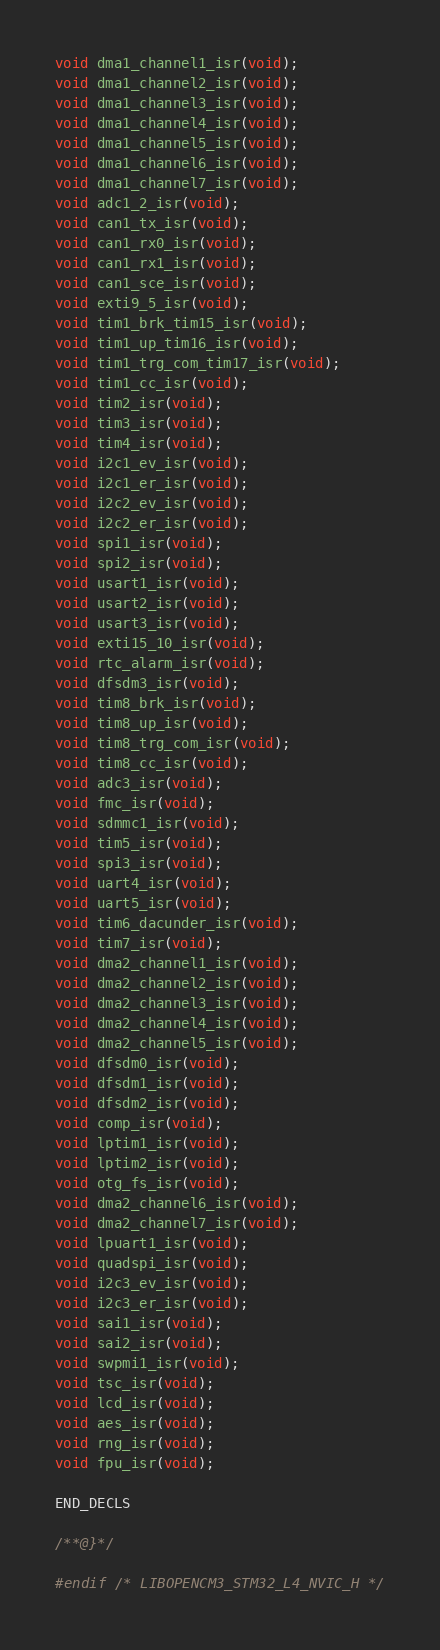<code> <loc_0><loc_0><loc_500><loc_500><_C_>void dma1_channel1_isr(void);
void dma1_channel2_isr(void);
void dma1_channel3_isr(void);
void dma1_channel4_isr(void);
void dma1_channel5_isr(void);
void dma1_channel6_isr(void);
void dma1_channel7_isr(void);
void adc1_2_isr(void);
void can1_tx_isr(void);
void can1_rx0_isr(void);
void can1_rx1_isr(void);
void can1_sce_isr(void);
void exti9_5_isr(void);
void tim1_brk_tim15_isr(void);
void tim1_up_tim16_isr(void);
void tim1_trg_com_tim17_isr(void);
void tim1_cc_isr(void);
void tim2_isr(void);
void tim3_isr(void);
void tim4_isr(void);
void i2c1_ev_isr(void);
void i2c1_er_isr(void);
void i2c2_ev_isr(void);
void i2c2_er_isr(void);
void spi1_isr(void);
void spi2_isr(void);
void usart1_isr(void);
void usart2_isr(void);
void usart3_isr(void);
void exti15_10_isr(void);
void rtc_alarm_isr(void);
void dfsdm3_isr(void);
void tim8_brk_isr(void);
void tim8_up_isr(void);
void tim8_trg_com_isr(void);
void tim8_cc_isr(void);
void adc3_isr(void);
void fmc_isr(void);
void sdmmc1_isr(void);
void tim5_isr(void);
void spi3_isr(void);
void uart4_isr(void);
void uart5_isr(void);
void tim6_dacunder_isr(void);
void tim7_isr(void);
void dma2_channel1_isr(void);
void dma2_channel2_isr(void);
void dma2_channel3_isr(void);
void dma2_channel4_isr(void);
void dma2_channel5_isr(void);
void dfsdm0_isr(void);
void dfsdm1_isr(void);
void dfsdm2_isr(void);
void comp_isr(void);
void lptim1_isr(void);
void lptim2_isr(void);
void otg_fs_isr(void);
void dma2_channel6_isr(void);
void dma2_channel7_isr(void);
void lpuart1_isr(void);
void quadspi_isr(void);
void i2c3_ev_isr(void);
void i2c3_er_isr(void);
void sai1_isr(void);
void sai2_isr(void);
void swpmi1_isr(void);
void tsc_isr(void);
void lcd_isr(void);
void aes_isr(void);
void rng_isr(void);
void fpu_isr(void);

END_DECLS

/**@}*/

#endif /* LIBOPENCM3_STM32_L4_NVIC_H */
</code> 